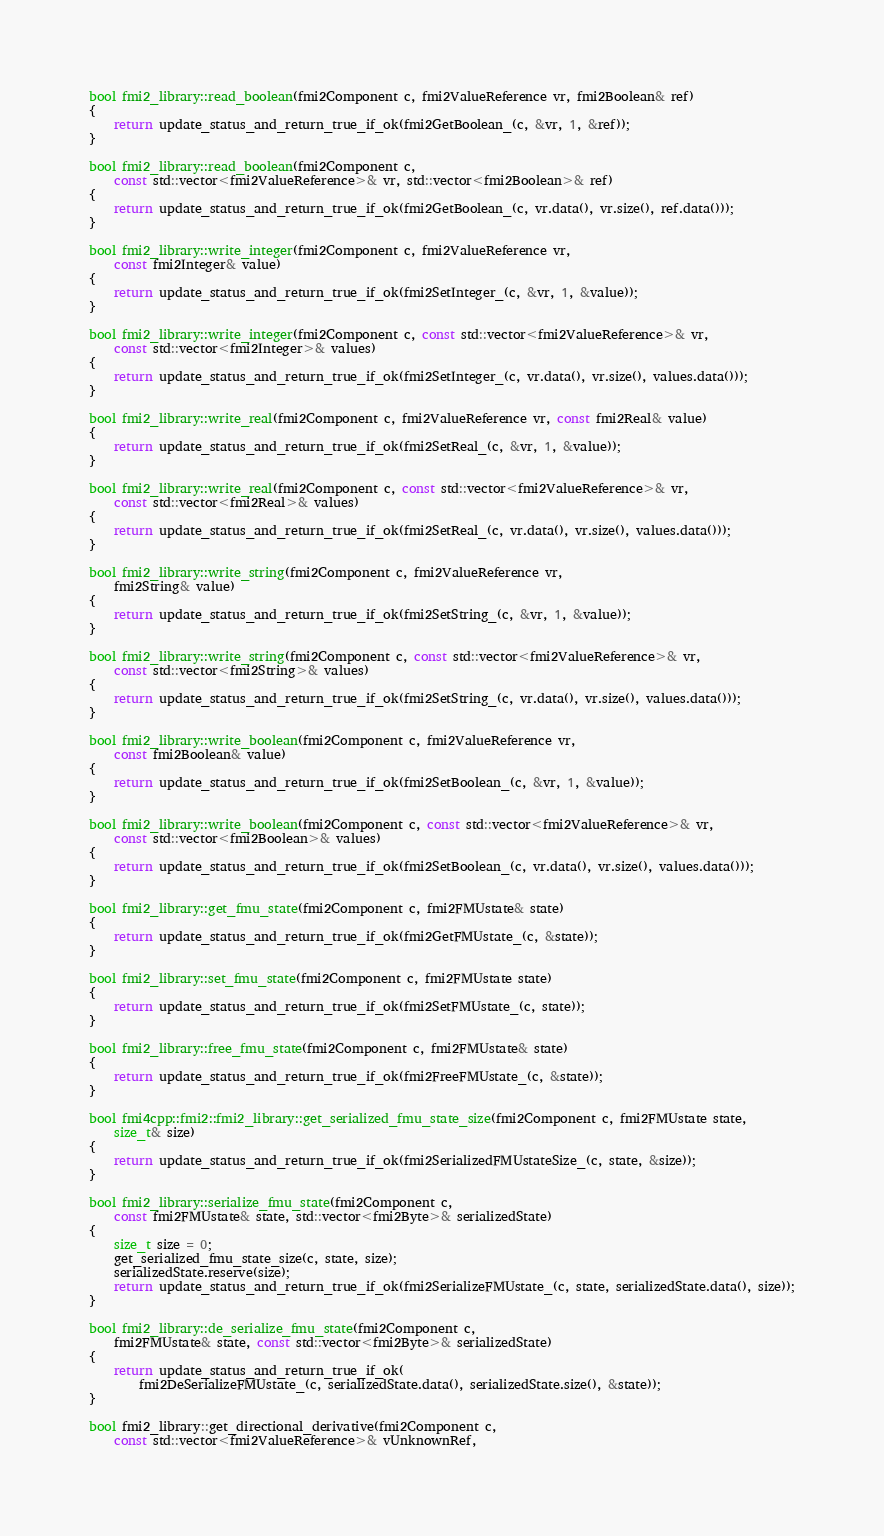Convert code to text. <code><loc_0><loc_0><loc_500><loc_500><_C++_>
bool fmi2_library::read_boolean(fmi2Component c, fmi2ValueReference vr, fmi2Boolean& ref)
{
    return update_status_and_return_true_if_ok(fmi2GetBoolean_(c, &vr, 1, &ref));
}

bool fmi2_library::read_boolean(fmi2Component c,
    const std::vector<fmi2ValueReference>& vr, std::vector<fmi2Boolean>& ref)
{
    return update_status_and_return_true_if_ok(fmi2GetBoolean_(c, vr.data(), vr.size(), ref.data()));
}

bool fmi2_library::write_integer(fmi2Component c, fmi2ValueReference vr,
    const fmi2Integer& value)
{
    return update_status_and_return_true_if_ok(fmi2SetInteger_(c, &vr, 1, &value));
}

bool fmi2_library::write_integer(fmi2Component c, const std::vector<fmi2ValueReference>& vr,
    const std::vector<fmi2Integer>& values)
{
    return update_status_and_return_true_if_ok(fmi2SetInteger_(c, vr.data(), vr.size(), values.data()));
}

bool fmi2_library::write_real(fmi2Component c, fmi2ValueReference vr, const fmi2Real& value)
{
    return update_status_and_return_true_if_ok(fmi2SetReal_(c, &vr, 1, &value));
}

bool fmi2_library::write_real(fmi2Component c, const std::vector<fmi2ValueReference>& vr,
    const std::vector<fmi2Real>& values)
{
    return update_status_and_return_true_if_ok(fmi2SetReal_(c, vr.data(), vr.size(), values.data()));
}

bool fmi2_library::write_string(fmi2Component c, fmi2ValueReference vr,
    fmi2String& value)
{
    return update_status_and_return_true_if_ok(fmi2SetString_(c, &vr, 1, &value));
}

bool fmi2_library::write_string(fmi2Component c, const std::vector<fmi2ValueReference>& vr,
    const std::vector<fmi2String>& values)
{
    return update_status_and_return_true_if_ok(fmi2SetString_(c, vr.data(), vr.size(), values.data()));
}

bool fmi2_library::write_boolean(fmi2Component c, fmi2ValueReference vr,
    const fmi2Boolean& value)
{
    return update_status_and_return_true_if_ok(fmi2SetBoolean_(c, &vr, 1, &value));
}

bool fmi2_library::write_boolean(fmi2Component c, const std::vector<fmi2ValueReference>& vr,
    const std::vector<fmi2Boolean>& values)
{
    return update_status_and_return_true_if_ok(fmi2SetBoolean_(c, vr.data(), vr.size(), values.data()));
}

bool fmi2_library::get_fmu_state(fmi2Component c, fmi2FMUstate& state)
{
    return update_status_and_return_true_if_ok(fmi2GetFMUstate_(c, &state));
}

bool fmi2_library::set_fmu_state(fmi2Component c, fmi2FMUstate state)
{
    return update_status_and_return_true_if_ok(fmi2SetFMUstate_(c, state));
}

bool fmi2_library::free_fmu_state(fmi2Component c, fmi2FMUstate& state)
{
    return update_status_and_return_true_if_ok(fmi2FreeFMUstate_(c, &state));
}

bool fmi4cpp::fmi2::fmi2_library::get_serialized_fmu_state_size(fmi2Component c, fmi2FMUstate state,
    size_t& size)
{
    return update_status_and_return_true_if_ok(fmi2SerializedFMUstateSize_(c, state, &size));
}

bool fmi2_library::serialize_fmu_state(fmi2Component c,
    const fmi2FMUstate& state, std::vector<fmi2Byte>& serializedState)
{
    size_t size = 0;
    get_serialized_fmu_state_size(c, state, size);
    serializedState.reserve(size);
    return update_status_and_return_true_if_ok(fmi2SerializeFMUstate_(c, state, serializedState.data(), size));
}

bool fmi2_library::de_serialize_fmu_state(fmi2Component c,
    fmi2FMUstate& state, const std::vector<fmi2Byte>& serializedState)
{
    return update_status_and_return_true_if_ok(
        fmi2DeSerializeFMUstate_(c, serializedState.data(), serializedState.size(), &state));
}

bool fmi2_library::get_directional_derivative(fmi2Component c,
    const std::vector<fmi2ValueReference>& vUnknownRef,</code> 